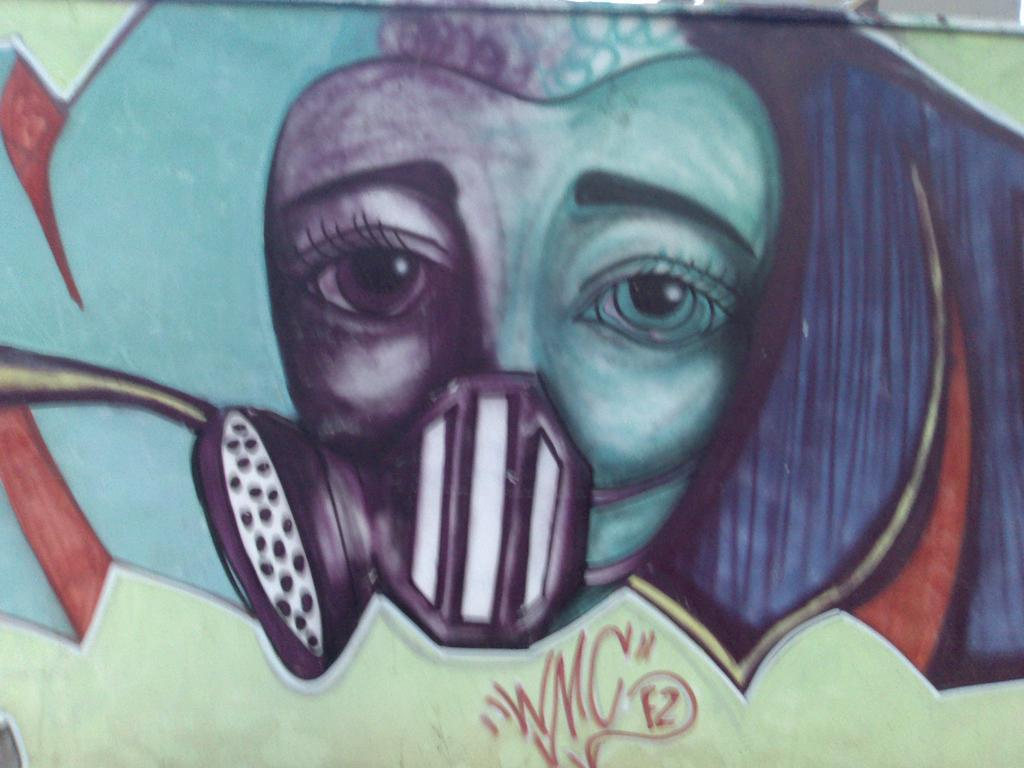What is present on the wall in the image? There is a painting on the wall in the image. What does the painting depict? The painting depicts a face. How many sisters are depicted in the painting on the wall? There are no sisters depicted in the painting on the wall; it only depicts a face. 